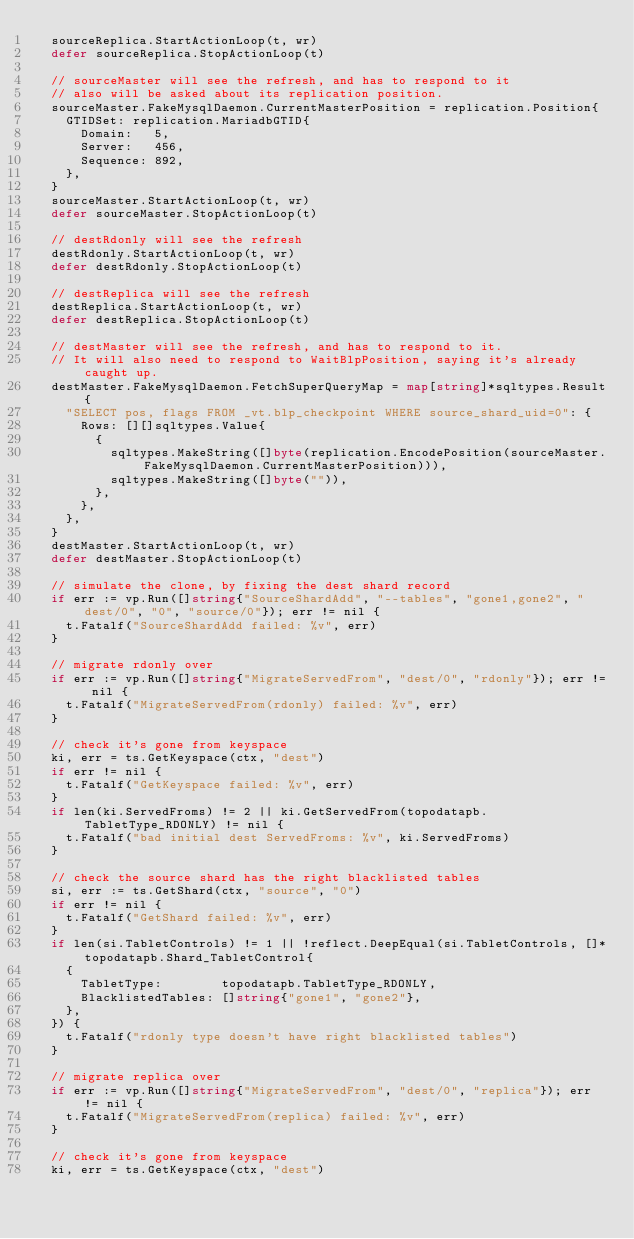Convert code to text. <code><loc_0><loc_0><loc_500><loc_500><_Go_>	sourceReplica.StartActionLoop(t, wr)
	defer sourceReplica.StopActionLoop(t)

	// sourceMaster will see the refresh, and has to respond to it
	// also will be asked about its replication position.
	sourceMaster.FakeMysqlDaemon.CurrentMasterPosition = replication.Position{
		GTIDSet: replication.MariadbGTID{
			Domain:   5,
			Server:   456,
			Sequence: 892,
		},
	}
	sourceMaster.StartActionLoop(t, wr)
	defer sourceMaster.StopActionLoop(t)

	// destRdonly will see the refresh
	destRdonly.StartActionLoop(t, wr)
	defer destRdonly.StopActionLoop(t)

	// destReplica will see the refresh
	destReplica.StartActionLoop(t, wr)
	defer destReplica.StopActionLoop(t)

	// destMaster will see the refresh, and has to respond to it.
	// It will also need to respond to WaitBlpPosition, saying it's already caught up.
	destMaster.FakeMysqlDaemon.FetchSuperQueryMap = map[string]*sqltypes.Result{
		"SELECT pos, flags FROM _vt.blp_checkpoint WHERE source_shard_uid=0": {
			Rows: [][]sqltypes.Value{
				{
					sqltypes.MakeString([]byte(replication.EncodePosition(sourceMaster.FakeMysqlDaemon.CurrentMasterPosition))),
					sqltypes.MakeString([]byte("")),
				},
			},
		},
	}
	destMaster.StartActionLoop(t, wr)
	defer destMaster.StopActionLoop(t)

	// simulate the clone, by fixing the dest shard record
	if err := vp.Run([]string{"SourceShardAdd", "--tables", "gone1,gone2", "dest/0", "0", "source/0"}); err != nil {
		t.Fatalf("SourceShardAdd failed: %v", err)
	}

	// migrate rdonly over
	if err := vp.Run([]string{"MigrateServedFrom", "dest/0", "rdonly"}); err != nil {
		t.Fatalf("MigrateServedFrom(rdonly) failed: %v", err)
	}

	// check it's gone from keyspace
	ki, err = ts.GetKeyspace(ctx, "dest")
	if err != nil {
		t.Fatalf("GetKeyspace failed: %v", err)
	}
	if len(ki.ServedFroms) != 2 || ki.GetServedFrom(topodatapb.TabletType_RDONLY) != nil {
		t.Fatalf("bad initial dest ServedFroms: %v", ki.ServedFroms)
	}

	// check the source shard has the right blacklisted tables
	si, err := ts.GetShard(ctx, "source", "0")
	if err != nil {
		t.Fatalf("GetShard failed: %v", err)
	}
	if len(si.TabletControls) != 1 || !reflect.DeepEqual(si.TabletControls, []*topodatapb.Shard_TabletControl{
		{
			TabletType:        topodatapb.TabletType_RDONLY,
			BlacklistedTables: []string{"gone1", "gone2"},
		},
	}) {
		t.Fatalf("rdonly type doesn't have right blacklisted tables")
	}

	// migrate replica over
	if err := vp.Run([]string{"MigrateServedFrom", "dest/0", "replica"}); err != nil {
		t.Fatalf("MigrateServedFrom(replica) failed: %v", err)
	}

	// check it's gone from keyspace
	ki, err = ts.GetKeyspace(ctx, "dest")</code> 